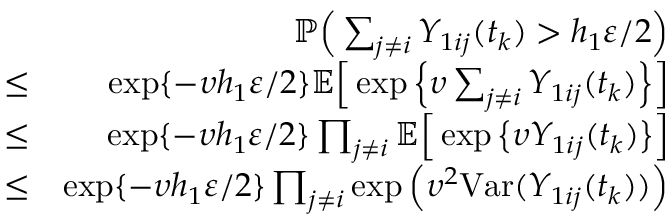Convert formula to latex. <formula><loc_0><loc_0><loc_500><loc_500>\begin{array} { r l r } & { \mathbb { P } \left ( \sum _ { j \neq i } Y _ { 1 i j } ( t _ { k } ) > h _ { 1 } \varepsilon / 2 \right ) } \\ & { \leq } & { \exp \{ - \upsilon h _ { 1 } \varepsilon / 2 \} \mathbb { E } \left [ \exp \left \{ \upsilon \sum _ { j \neq i } Y _ { 1 i j } ( t _ { k } ) \right \} \right ] } \\ & { \leq } & { \exp \{ - \upsilon h _ { 1 } \varepsilon / 2 \} \prod _ { j \neq i } \mathbb { E } \left [ \exp \left \{ \upsilon Y _ { 1 i j } ( t _ { k } ) \right \} \right ] } \\ & { \leq } & { \exp \{ - \upsilon h _ { 1 } \varepsilon / 2 \} \prod _ { j \neq i } \exp \left ( \upsilon ^ { 2 } V a r ( Y _ { 1 i j } ( t _ { k } ) ) \right ) } \end{array}</formula> 